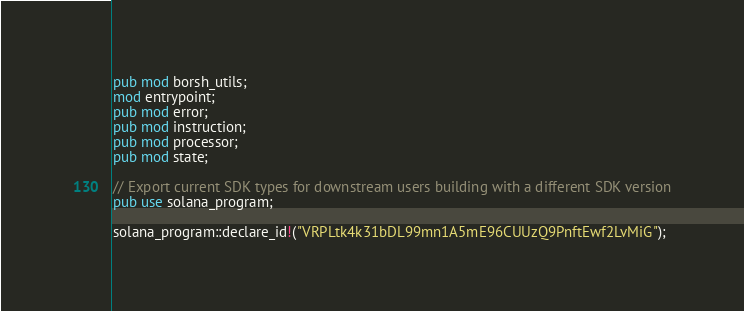Convert code to text. <code><loc_0><loc_0><loc_500><loc_500><_Rust_>pub mod borsh_utils;
mod entrypoint;
pub mod error;
pub mod instruction;
pub mod processor;
pub mod state;

// Export current SDK types for downstream users building with a different SDK version
pub use solana_program;

solana_program::declare_id!("VRPLtk4k31bDL99mn1A5mE96CUUzQ9PnftEwf2LvMiG");
</code> 